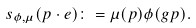<formula> <loc_0><loc_0><loc_500><loc_500>s _ { \phi , \mu } ( p \cdot e ) \colon = \mu ( p ) \phi ( g p ) .</formula> 